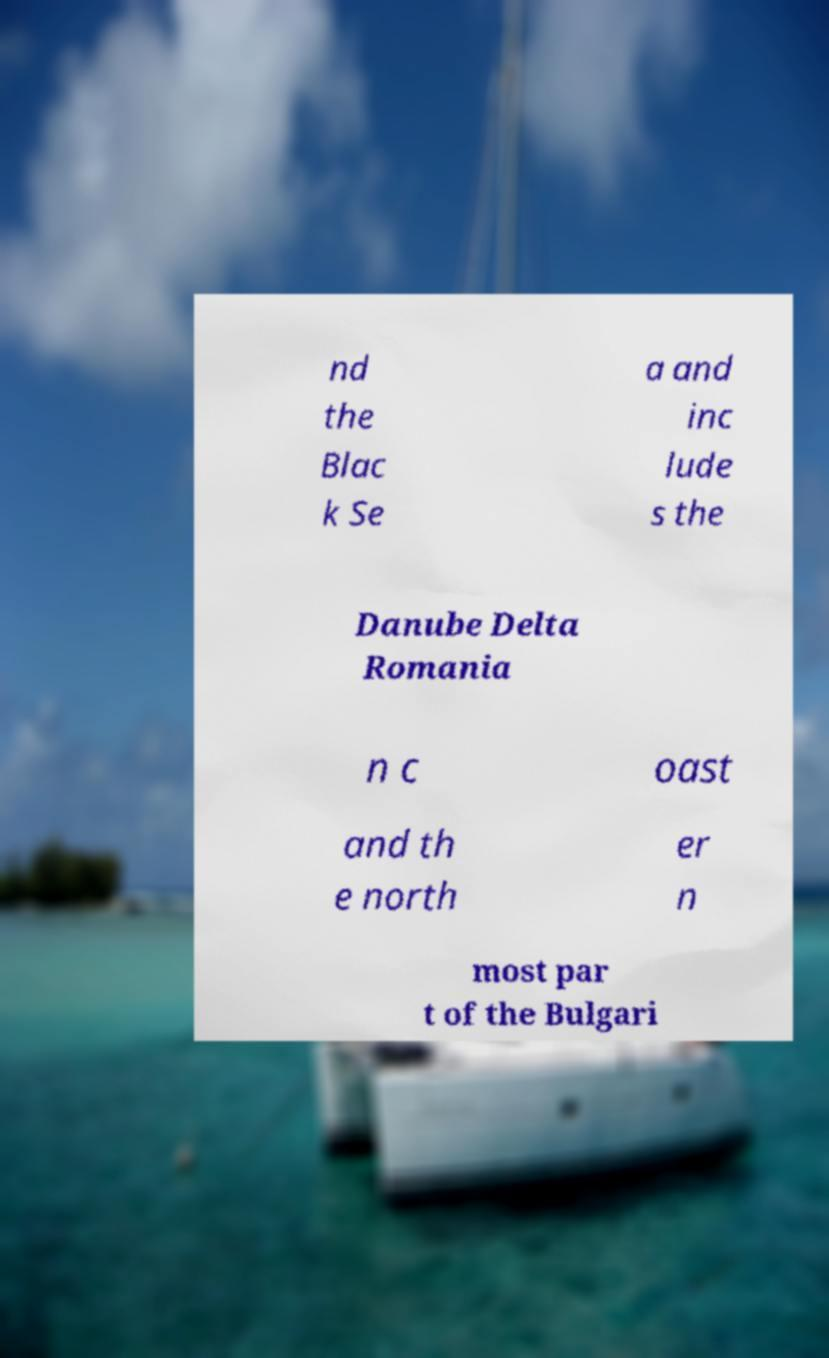There's text embedded in this image that I need extracted. Can you transcribe it verbatim? nd the Blac k Se a and inc lude s the Danube Delta Romania n c oast and th e north er n most par t of the Bulgari 